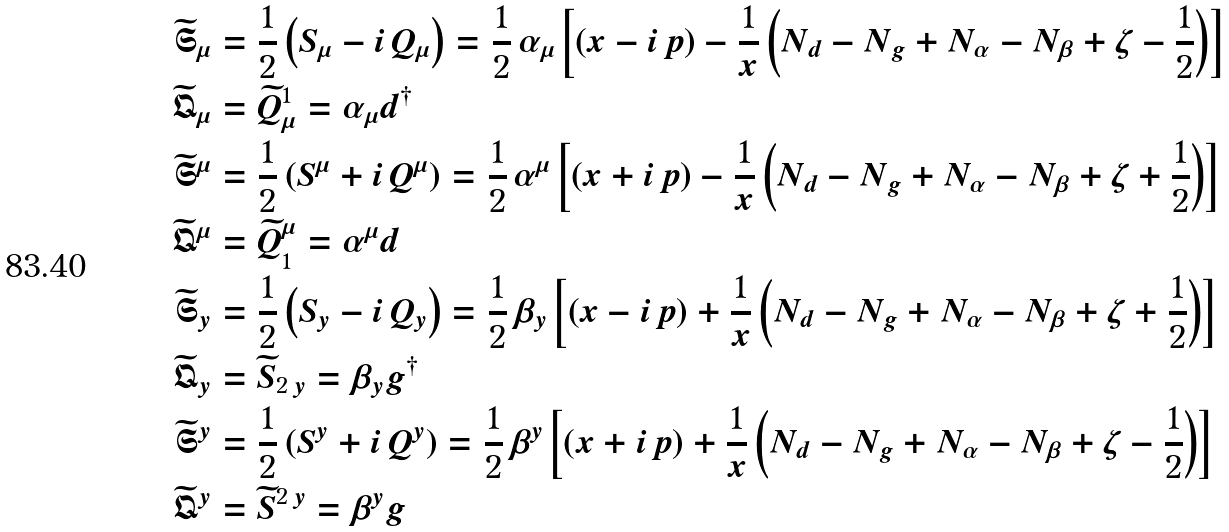<formula> <loc_0><loc_0><loc_500><loc_500>\widetilde { \mathfrak { S } } _ { \mu } & = \frac { 1 } { 2 } \left ( S _ { \mu } - i \, Q _ { \mu } \right ) = \frac { 1 } { 2 } \, \alpha _ { \mu } \left [ \left ( x - i \, p \right ) - \frac { 1 } { x } \left ( N _ { d } - N _ { g } + N _ { \alpha } - N _ { \beta } + \zeta - \frac { 1 } { 2 } \right ) \right ] \\ \widetilde { \mathfrak { Q } } _ { \mu } & = \widetilde { Q } _ { \mu } ^ { 1 } = \alpha _ { \mu } d ^ { \dag } \\ \widetilde { \mathfrak { S } } ^ { \mu } & = \frac { 1 } { 2 } \left ( S ^ { \mu } + i \, Q ^ { \mu } \right ) = \frac { 1 } { 2 } \, \alpha ^ { \mu } \left [ \left ( x + i \, p \right ) - \frac { 1 } { x } \left ( N _ { d } - N _ { g } + N _ { \alpha } - N _ { \beta } + \zeta + \frac { 1 } { 2 } \right ) \right ] \\ \widetilde { \mathfrak { Q } } ^ { \mu } & = \widetilde { Q } ^ { \mu } _ { 1 } = \alpha ^ { \mu } d \\ \widetilde { \mathfrak { S } } _ { y } & = \frac { 1 } { 2 } \left ( S _ { y } - i \, Q _ { y } \right ) = \frac { 1 } { 2 } \, \beta _ { y } \left [ \left ( x - i \, p \right ) + \frac { 1 } { x } \left ( N _ { d } - N _ { g } + N _ { \alpha } - N _ { \beta } + \zeta + \frac { 1 } { 2 } \right ) \right ] \\ \widetilde { \mathfrak { Q } } _ { y } & = \widetilde { S } _ { 2 \, y } = \beta _ { y } g ^ { \dag } \\ \widetilde { \mathfrak { S } } ^ { y } & = \frac { 1 } { 2 } \left ( S ^ { y } + i \, Q ^ { y } \right ) = \frac { 1 } { 2 } \, \beta ^ { y } \left [ \left ( x + i \, p \right ) + \frac { 1 } { x } \left ( N _ { d } - N _ { g } + N _ { \alpha } - N _ { \beta } + \zeta - \frac { 1 } { 2 } \right ) \right ] \\ \widetilde { \mathfrak { Q } } ^ { y } & = \widetilde { S } ^ { 2 \, y } = \beta ^ { y } g</formula> 